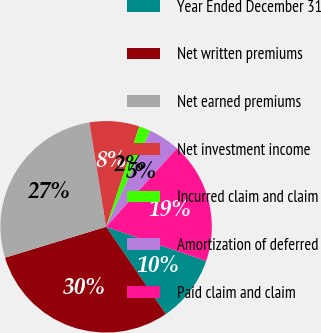<chart> <loc_0><loc_0><loc_500><loc_500><pie_chart><fcel>Year Ended December 31<fcel>Net written premiums<fcel>Net earned premiums<fcel>Net investment income<fcel>Incurred claim and claim<fcel>Amortization of deferred<fcel>Paid claim and claim<nl><fcel>10.22%<fcel>29.83%<fcel>27.2%<fcel>7.6%<fcel>1.77%<fcel>4.84%<fcel>18.53%<nl></chart> 